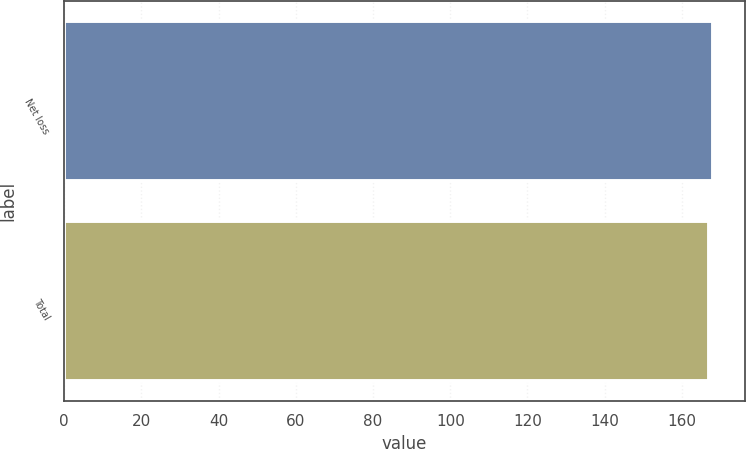Convert chart. <chart><loc_0><loc_0><loc_500><loc_500><bar_chart><fcel>Net loss<fcel>Total<nl><fcel>168<fcel>167<nl></chart> 